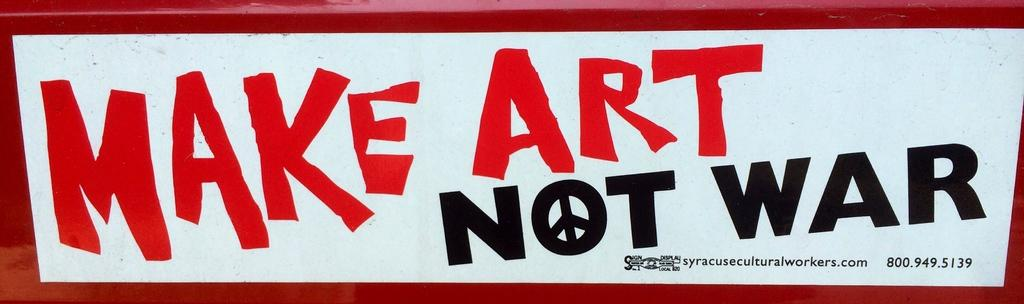Provide a one-sentence caption for the provided image. A poster that reads make art not war. 